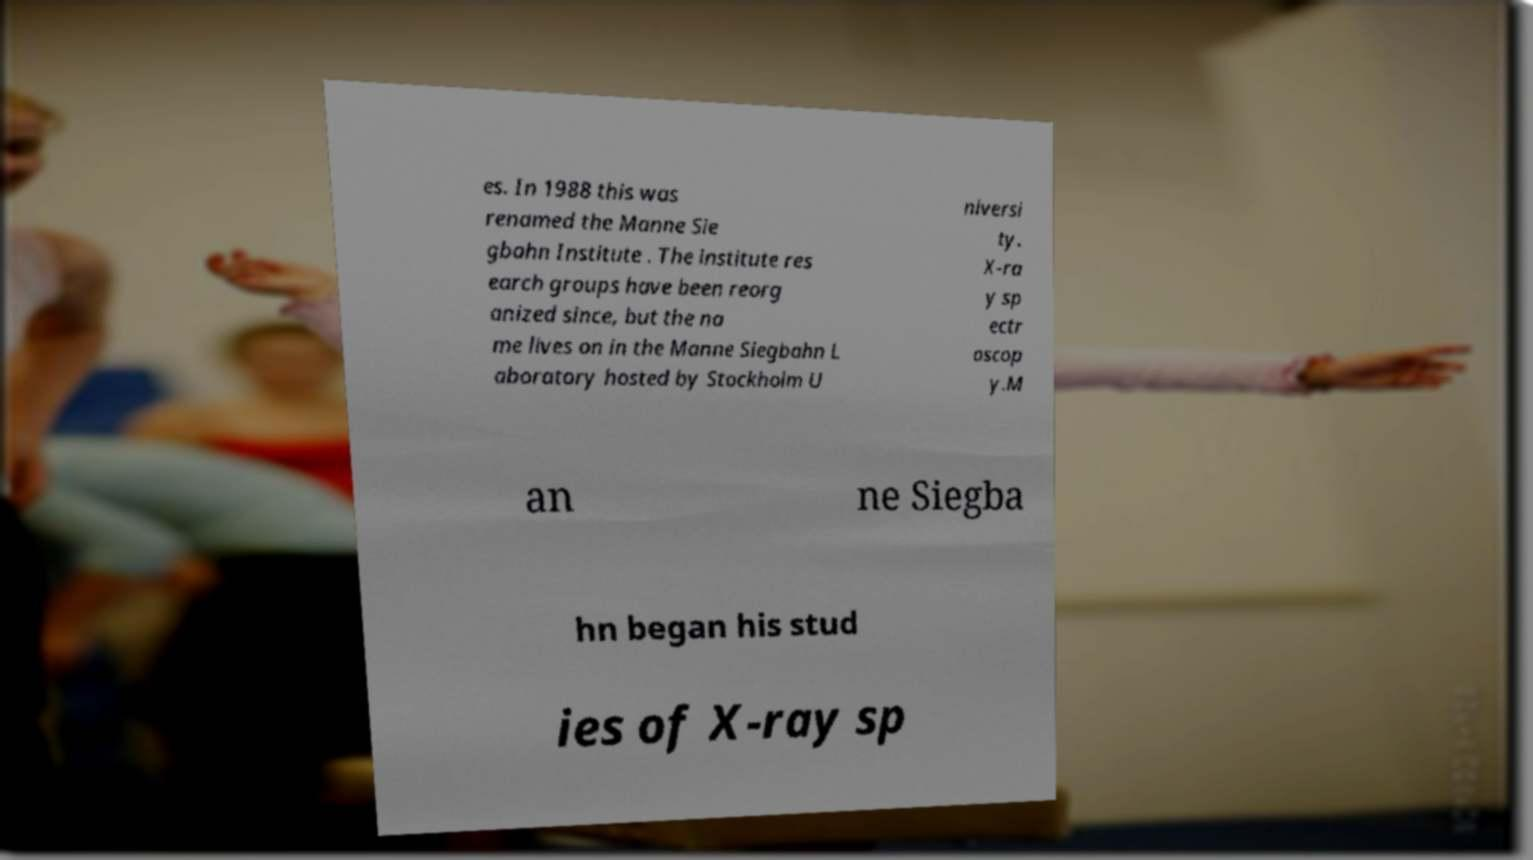There's text embedded in this image that I need extracted. Can you transcribe it verbatim? es. In 1988 this was renamed the Manne Sie gbahn Institute . The institute res earch groups have been reorg anized since, but the na me lives on in the Manne Siegbahn L aboratory hosted by Stockholm U niversi ty. X-ra y sp ectr oscop y.M an ne Siegba hn began his stud ies of X-ray sp 